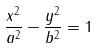<formula> <loc_0><loc_0><loc_500><loc_500>\frac { x ^ { 2 } } { a ^ { 2 } } - \frac { y ^ { 2 } } { b ^ { 2 } } = 1</formula> 